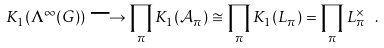Convert formula to latex. <formula><loc_0><loc_0><loc_500><loc_500>K _ { 1 } ( \Lambda ^ { \infty } ( G ) ) \longrightarrow \prod _ { \pi } K _ { 1 } ( \mathcal { A } _ { \pi } ) \cong \prod _ { \pi } K _ { 1 } ( L _ { \pi } ) = \prod _ { \pi } L _ { \pi } ^ { \times } \ .</formula> 